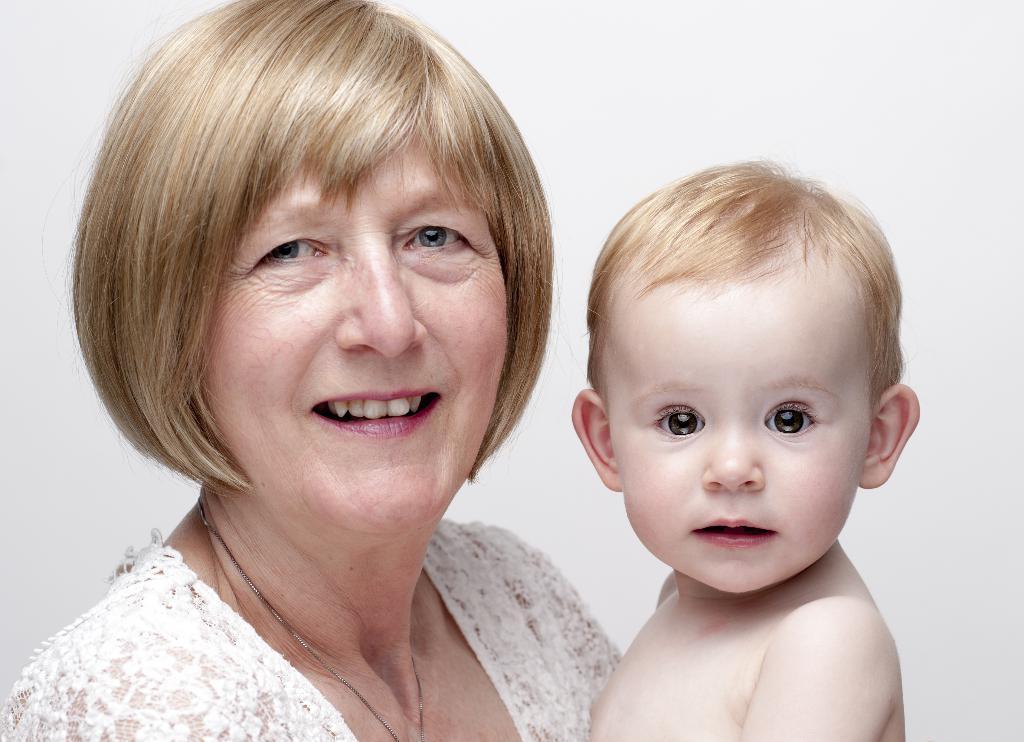Please provide a concise description of this image. In this image, we can see a woman standing and she is holding a kid, there is a white background. 